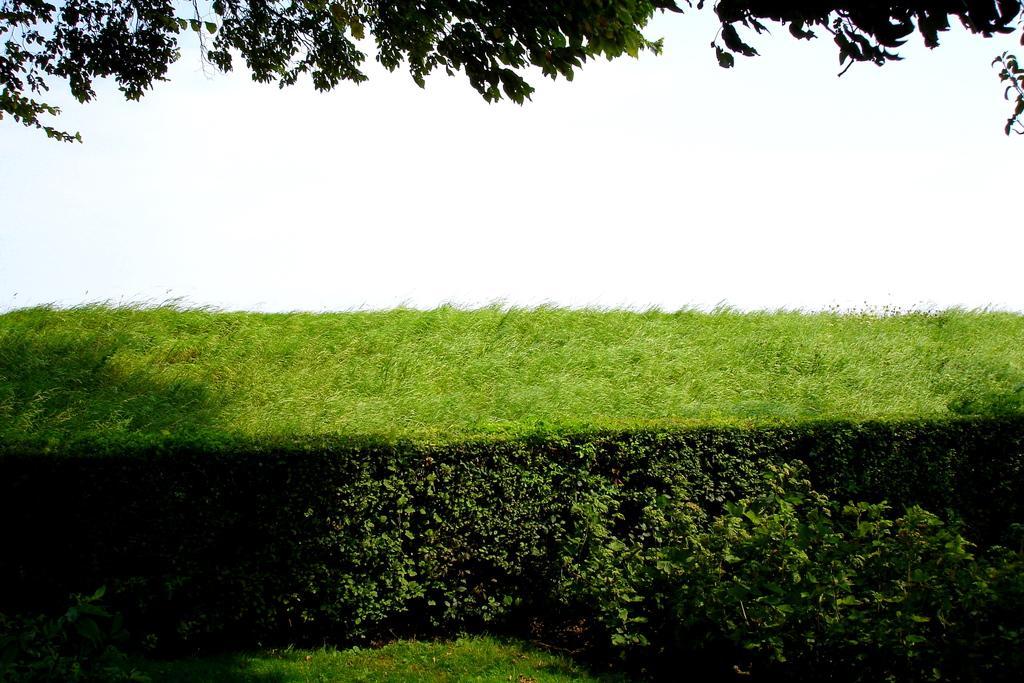In one or two sentences, can you explain what this image depicts? In this image you can see a bush, at the top of the image there are trees. 